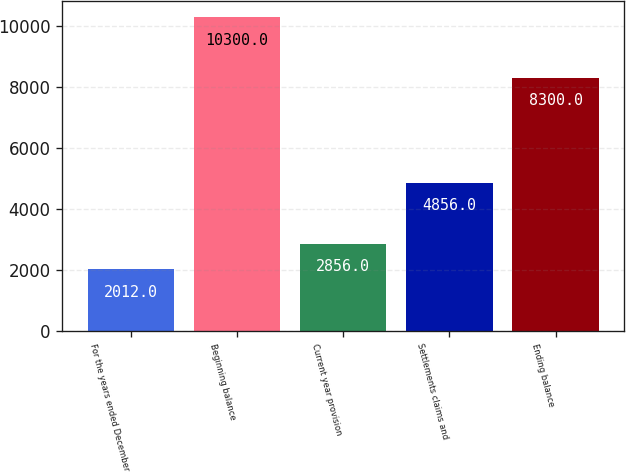<chart> <loc_0><loc_0><loc_500><loc_500><bar_chart><fcel>For the years ended December<fcel>Beginning balance<fcel>Current year provision<fcel>Settlements claims and<fcel>Ending balance<nl><fcel>2012<fcel>10300<fcel>2856<fcel>4856<fcel>8300<nl></chart> 